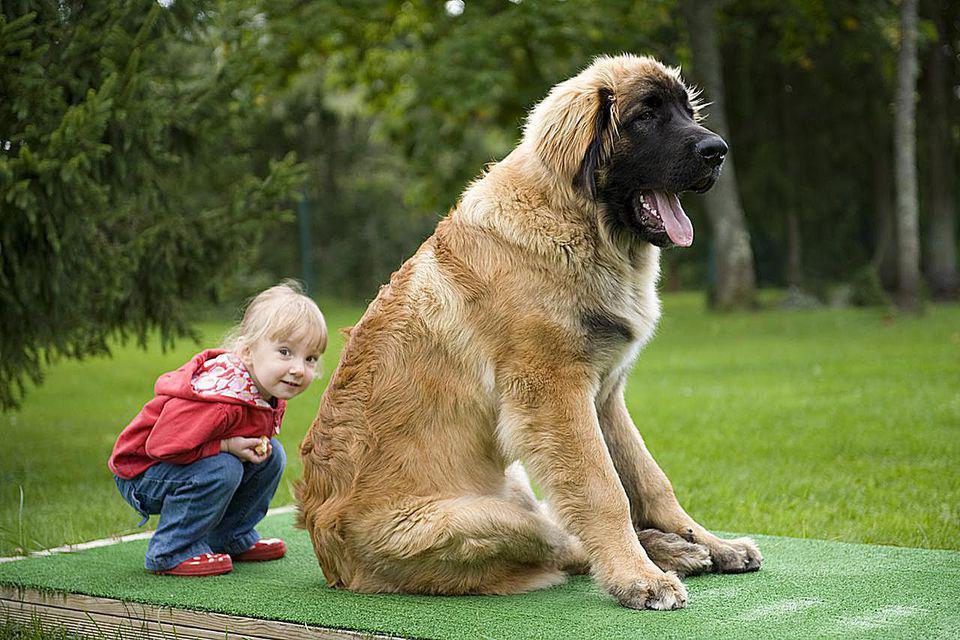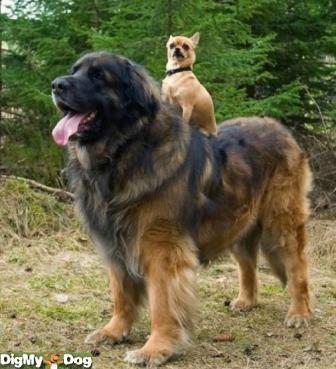The first image is the image on the left, the second image is the image on the right. Given the left and right images, does the statement "A child wearing a red jacket is with a dog." hold true? Answer yes or no. Yes. 